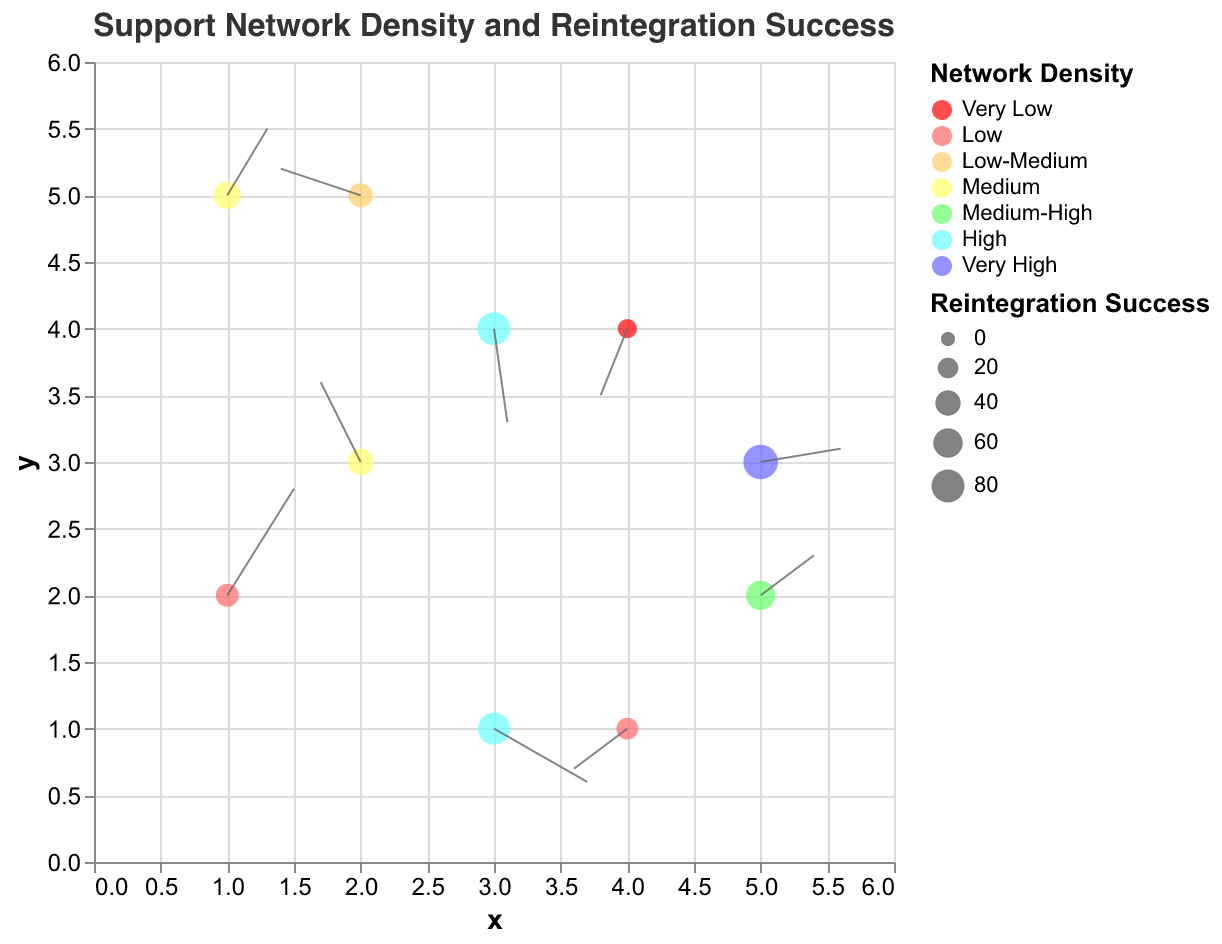What is the title of the figure? The title of the figure can be found at the top of the chart. It reads "Support Network Density and Reintegration Success".
Answer: Support Network Density and Reintegration Success How many different categories of network density are represented in the figure? The legend shows various colors representing different categories of network density. By counting them, we find there are seven categories.
Answer: Seven Which data point represents the highest reintegration success? Each data point's size represents the reintegration success rate. The largest circle corresponds to this data point. We observe it occurs at (5, 3) with a value of 90.
Answer: (5,3) What is the average reintegration success rate of data points with high network density? Data points with "High" network density are found at (3, 1) with 75 and (3, 4) with 80 reintegration success rates. The average is (75 + 80) / 2 = 77.5.
Answer: 77.5 Compare the direction of the vector for the points (1, 2) and (2, 3). Which one generally shows a stronger upwards influence? The vector at (1, 2) has components (0.5, 0.8), giving a magnitude of 0.94 with an upwards component of 0.8, whereas the vector at (2, 3) has components (-0.3, 0.6), giving a magnitude of 0.67 with an upwards component of 0.6. Since 0.8 > 0.6, (1, 2) shows a stronger upwards influence.
Answer: (1, 2) Which data point shows a substantial downward influence and what is its reintegration success rate? We identify the points with downward vectors by looking at the rule arrows pointing downwards. The point at (3, 4) has a downward component of -0.7 and a success rate of 80.
Answer: (3, 4) What is the color representing a medium network density? The legend associates colors with different network densities. "Medium" is represented by a yellowish-green color.
Answer: Yellowish-green Is there a trend between the network density and reintegration success? By analyzing the colors and corresponding data point sizes, we observe that generally, higher network density (bluer colors) is associated with larger point sizes, indicating higher reintegration success rates.
Answer: Yes Which data point has a vector mostly pointing left and what's the network density there? We need to find the datum with a negative 'u' component that's relatively large. The point at (2, 5) with vector (-0.6, 0.2) mostly points left, and its network density is Low-Medium.
Answer: (2, 5), Low-Medium 